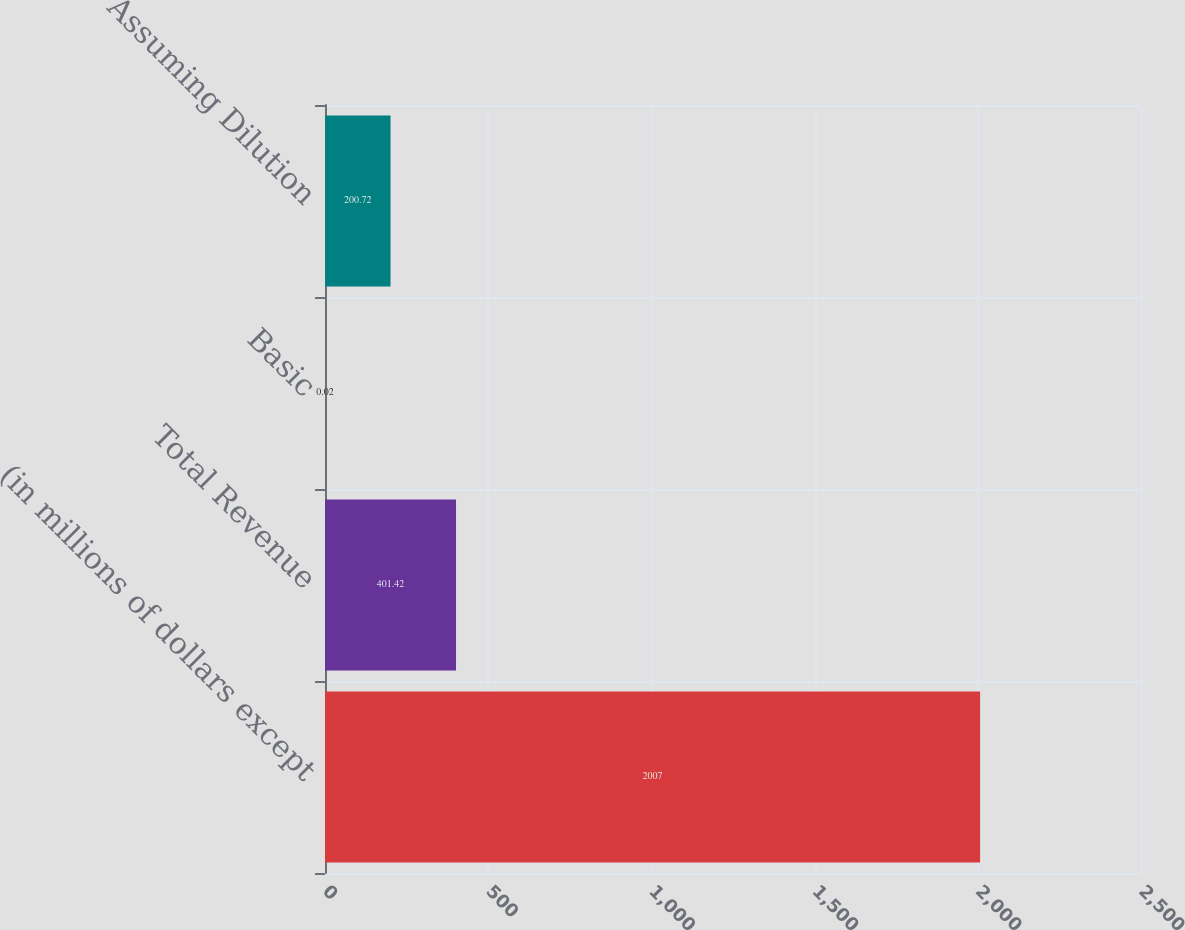Convert chart to OTSL. <chart><loc_0><loc_0><loc_500><loc_500><bar_chart><fcel>(in millions of dollars except<fcel>Total Revenue<fcel>Basic<fcel>Assuming Dilution<nl><fcel>2007<fcel>401.42<fcel>0.02<fcel>200.72<nl></chart> 